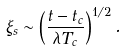Convert formula to latex. <formula><loc_0><loc_0><loc_500><loc_500>\xi _ { s } \sim \left ( \frac { t - t _ { c } } { \lambda T _ { c } } \right ) ^ { 1 / 2 } .</formula> 